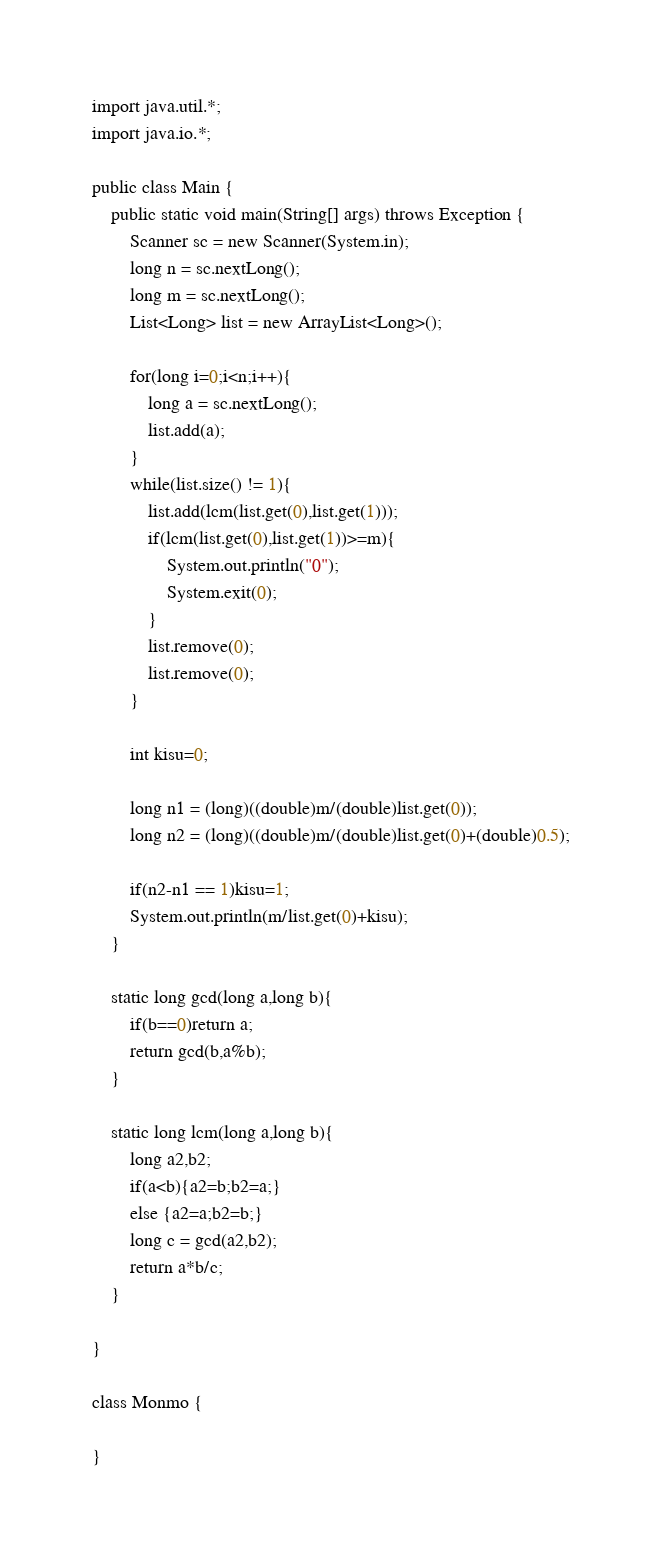<code> <loc_0><loc_0><loc_500><loc_500><_Java_>import java.util.*;
import java.io.*;

public class Main {
    public static void main(String[] args) throws Exception {
        Scanner sc = new Scanner(System.in);
        long n = sc.nextLong();
        long m = sc.nextLong();
        List<Long> list = new ArrayList<Long>();
        
        for(long i=0;i<n;i++){
            long a = sc.nextLong();
            list.add(a);
        }
        while(list.size() != 1){
            list.add(lcm(list.get(0),list.get(1)));
            if(lcm(list.get(0),list.get(1))>=m){
                System.out.println("0");
                System.exit(0);
            }
            list.remove(0);
            list.remove(0);
        }
        
        int kisu=0;
        
        long n1 = (long)((double)m/(double)list.get(0));
        long n2 = (long)((double)m/(double)list.get(0)+(double)0.5);
 
        if(n2-n1 == 1)kisu=1;
        System.out.println(m/list.get(0)+kisu);
    }
    
    static long gcd(long a,long b){
        if(b==0)return a;
        return gcd(b,a%b);
    }
    
    static long lcm(long a,long b){
        long a2,b2;
        if(a<b){a2=b;b2=a;}
        else {a2=a;b2=b;}
        long c = gcd(a2,b2);
        return a*b/c;
    }
    
}

class Monmo {
    
}

</code> 